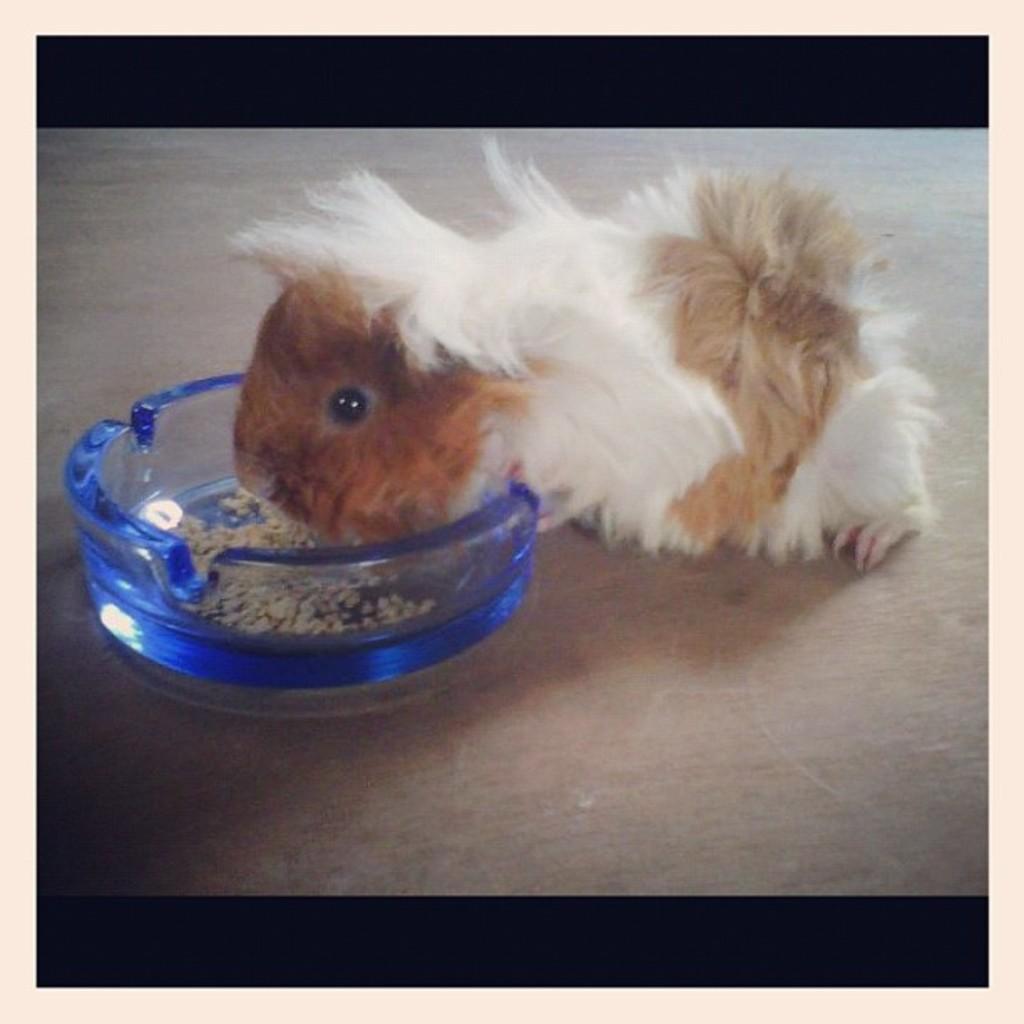How would you summarize this image in a sentence or two? In this image I see an animal, which is of white and brown in color and there is a bowl in front of it which is of blue in color and there is food in it. 